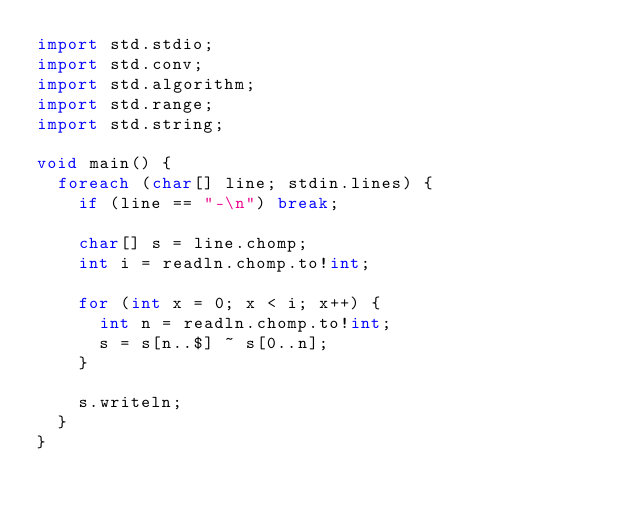Convert code to text. <code><loc_0><loc_0><loc_500><loc_500><_D_>import std.stdio;
import std.conv;
import std.algorithm;
import std.range;
import std.string;

void main() {
  foreach (char[] line; stdin.lines) {
    if (line == "-\n") break;

    char[] s = line.chomp;
    int i = readln.chomp.to!int;

    for (int x = 0; x < i; x++) {
      int n = readln.chomp.to!int;
      s = s[n..$] ~ s[0..n];
    }

    s.writeln;
  }
}</code> 